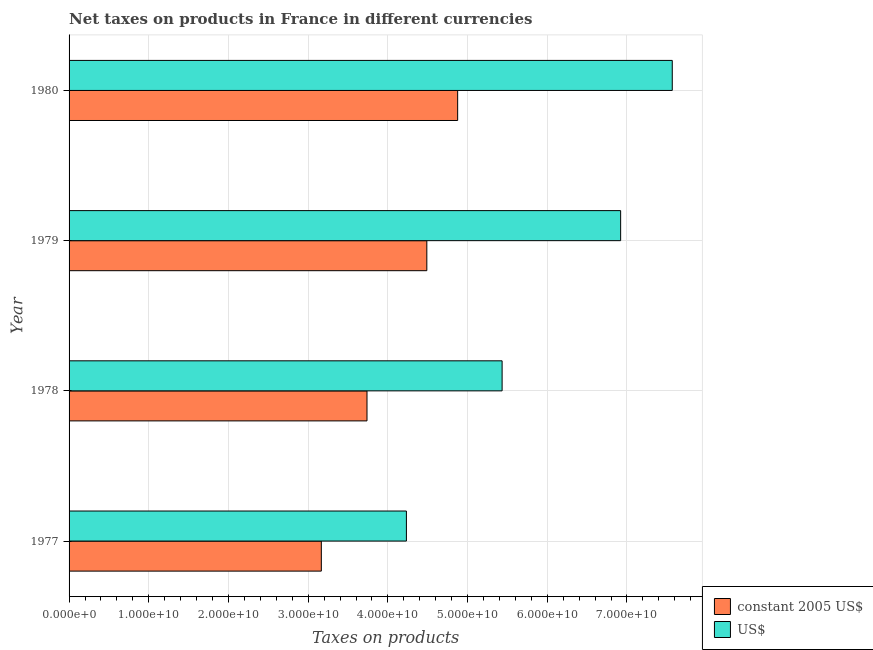How many different coloured bars are there?
Your response must be concise. 2. Are the number of bars per tick equal to the number of legend labels?
Ensure brevity in your answer.  Yes. Are the number of bars on each tick of the Y-axis equal?
Your response must be concise. Yes. How many bars are there on the 4th tick from the top?
Make the answer very short. 2. How many bars are there on the 1st tick from the bottom?
Give a very brief answer. 2. What is the label of the 3rd group of bars from the top?
Provide a short and direct response. 1978. What is the net taxes in constant 2005 us$ in 1977?
Make the answer very short. 3.17e+1. Across all years, what is the maximum net taxes in us$?
Provide a short and direct response. 7.57e+1. Across all years, what is the minimum net taxes in constant 2005 us$?
Offer a terse response. 3.17e+1. What is the total net taxes in us$ in the graph?
Give a very brief answer. 2.42e+11. What is the difference between the net taxes in constant 2005 us$ in 1977 and that in 1980?
Your answer should be compact. -1.71e+1. What is the difference between the net taxes in constant 2005 us$ in 1978 and the net taxes in us$ in 1977?
Provide a short and direct response. -4.94e+09. What is the average net taxes in constant 2005 us$ per year?
Ensure brevity in your answer.  4.07e+1. In the year 1978, what is the difference between the net taxes in us$ and net taxes in constant 2005 us$?
Give a very brief answer. 1.70e+1. In how many years, is the net taxes in us$ greater than 76000000000 units?
Offer a terse response. 0. What is the ratio of the net taxes in us$ in 1977 to that in 1979?
Give a very brief answer. 0.61. Is the difference between the net taxes in constant 2005 us$ in 1979 and 1980 greater than the difference between the net taxes in us$ in 1979 and 1980?
Provide a succinct answer. Yes. What is the difference between the highest and the second highest net taxes in us$?
Provide a succinct answer. 6.48e+09. What is the difference between the highest and the lowest net taxes in constant 2005 us$?
Provide a short and direct response. 1.71e+1. In how many years, is the net taxes in us$ greater than the average net taxes in us$ taken over all years?
Offer a terse response. 2. What does the 2nd bar from the top in 1978 represents?
Give a very brief answer. Constant 2005 us$. What does the 1st bar from the bottom in 1979 represents?
Make the answer very short. Constant 2005 us$. Are all the bars in the graph horizontal?
Offer a very short reply. Yes. How many years are there in the graph?
Your answer should be compact. 4. What is the difference between two consecutive major ticks on the X-axis?
Offer a very short reply. 1.00e+1. Are the values on the major ticks of X-axis written in scientific E-notation?
Provide a succinct answer. Yes. Does the graph contain grids?
Ensure brevity in your answer.  Yes. How are the legend labels stacked?
Make the answer very short. Vertical. What is the title of the graph?
Make the answer very short. Net taxes on products in France in different currencies. What is the label or title of the X-axis?
Provide a succinct answer. Taxes on products. What is the Taxes on products of constant 2005 US$ in 1977?
Make the answer very short. 3.17e+1. What is the Taxes on products in US$ in 1977?
Give a very brief answer. 4.23e+1. What is the Taxes on products in constant 2005 US$ in 1978?
Offer a terse response. 3.74e+1. What is the Taxes on products of US$ in 1978?
Make the answer very short. 5.43e+1. What is the Taxes on products of constant 2005 US$ in 1979?
Your response must be concise. 4.49e+1. What is the Taxes on products in US$ in 1979?
Provide a succinct answer. 6.92e+1. What is the Taxes on products of constant 2005 US$ in 1980?
Your answer should be very brief. 4.88e+1. What is the Taxes on products of US$ in 1980?
Offer a very short reply. 7.57e+1. Across all years, what is the maximum Taxes on products of constant 2005 US$?
Your response must be concise. 4.88e+1. Across all years, what is the maximum Taxes on products of US$?
Provide a succinct answer. 7.57e+1. Across all years, what is the minimum Taxes on products in constant 2005 US$?
Provide a succinct answer. 3.17e+1. Across all years, what is the minimum Taxes on products of US$?
Ensure brevity in your answer.  4.23e+1. What is the total Taxes on products of constant 2005 US$ in the graph?
Keep it short and to the point. 1.63e+11. What is the total Taxes on products of US$ in the graph?
Ensure brevity in your answer.  2.42e+11. What is the difference between the Taxes on products of constant 2005 US$ in 1977 and that in 1978?
Provide a short and direct response. -5.73e+09. What is the difference between the Taxes on products in US$ in 1977 and that in 1978?
Your response must be concise. -1.20e+1. What is the difference between the Taxes on products in constant 2005 US$ in 1977 and that in 1979?
Offer a very short reply. -1.32e+1. What is the difference between the Taxes on products in US$ in 1977 and that in 1979?
Offer a very short reply. -2.69e+1. What is the difference between the Taxes on products of constant 2005 US$ in 1977 and that in 1980?
Your response must be concise. -1.71e+1. What is the difference between the Taxes on products of US$ in 1977 and that in 1980?
Offer a terse response. -3.34e+1. What is the difference between the Taxes on products of constant 2005 US$ in 1978 and that in 1979?
Provide a short and direct response. -7.51e+09. What is the difference between the Taxes on products in US$ in 1978 and that in 1979?
Provide a succinct answer. -1.49e+1. What is the difference between the Taxes on products of constant 2005 US$ in 1978 and that in 1980?
Provide a short and direct response. -1.14e+1. What is the difference between the Taxes on products in US$ in 1978 and that in 1980?
Your answer should be compact. -2.14e+1. What is the difference between the Taxes on products in constant 2005 US$ in 1979 and that in 1980?
Make the answer very short. -3.87e+09. What is the difference between the Taxes on products in US$ in 1979 and that in 1980?
Provide a succinct answer. -6.48e+09. What is the difference between the Taxes on products of constant 2005 US$ in 1977 and the Taxes on products of US$ in 1978?
Provide a short and direct response. -2.27e+1. What is the difference between the Taxes on products of constant 2005 US$ in 1977 and the Taxes on products of US$ in 1979?
Keep it short and to the point. -3.76e+1. What is the difference between the Taxes on products of constant 2005 US$ in 1977 and the Taxes on products of US$ in 1980?
Make the answer very short. -4.40e+1. What is the difference between the Taxes on products of constant 2005 US$ in 1978 and the Taxes on products of US$ in 1979?
Provide a short and direct response. -3.18e+1. What is the difference between the Taxes on products in constant 2005 US$ in 1978 and the Taxes on products in US$ in 1980?
Provide a short and direct response. -3.83e+1. What is the difference between the Taxes on products in constant 2005 US$ in 1979 and the Taxes on products in US$ in 1980?
Your answer should be compact. -3.08e+1. What is the average Taxes on products of constant 2005 US$ per year?
Keep it short and to the point. 4.07e+1. What is the average Taxes on products in US$ per year?
Make the answer very short. 6.04e+1. In the year 1977, what is the difference between the Taxes on products of constant 2005 US$ and Taxes on products of US$?
Your answer should be compact. -1.07e+1. In the year 1978, what is the difference between the Taxes on products in constant 2005 US$ and Taxes on products in US$?
Your answer should be very brief. -1.70e+1. In the year 1979, what is the difference between the Taxes on products in constant 2005 US$ and Taxes on products in US$?
Ensure brevity in your answer.  -2.43e+1. In the year 1980, what is the difference between the Taxes on products of constant 2005 US$ and Taxes on products of US$?
Provide a succinct answer. -2.69e+1. What is the ratio of the Taxes on products in constant 2005 US$ in 1977 to that in 1978?
Give a very brief answer. 0.85. What is the ratio of the Taxes on products of US$ in 1977 to that in 1978?
Keep it short and to the point. 0.78. What is the ratio of the Taxes on products in constant 2005 US$ in 1977 to that in 1979?
Provide a succinct answer. 0.71. What is the ratio of the Taxes on products in US$ in 1977 to that in 1979?
Offer a terse response. 0.61. What is the ratio of the Taxes on products in constant 2005 US$ in 1977 to that in 1980?
Offer a terse response. 0.65. What is the ratio of the Taxes on products of US$ in 1977 to that in 1980?
Give a very brief answer. 0.56. What is the ratio of the Taxes on products of constant 2005 US$ in 1978 to that in 1979?
Keep it short and to the point. 0.83. What is the ratio of the Taxes on products in US$ in 1978 to that in 1979?
Offer a very short reply. 0.79. What is the ratio of the Taxes on products in constant 2005 US$ in 1978 to that in 1980?
Provide a short and direct response. 0.77. What is the ratio of the Taxes on products of US$ in 1978 to that in 1980?
Offer a terse response. 0.72. What is the ratio of the Taxes on products in constant 2005 US$ in 1979 to that in 1980?
Give a very brief answer. 0.92. What is the ratio of the Taxes on products of US$ in 1979 to that in 1980?
Your answer should be very brief. 0.91. What is the difference between the highest and the second highest Taxes on products of constant 2005 US$?
Your answer should be compact. 3.87e+09. What is the difference between the highest and the second highest Taxes on products of US$?
Offer a terse response. 6.48e+09. What is the difference between the highest and the lowest Taxes on products in constant 2005 US$?
Make the answer very short. 1.71e+1. What is the difference between the highest and the lowest Taxes on products in US$?
Provide a short and direct response. 3.34e+1. 